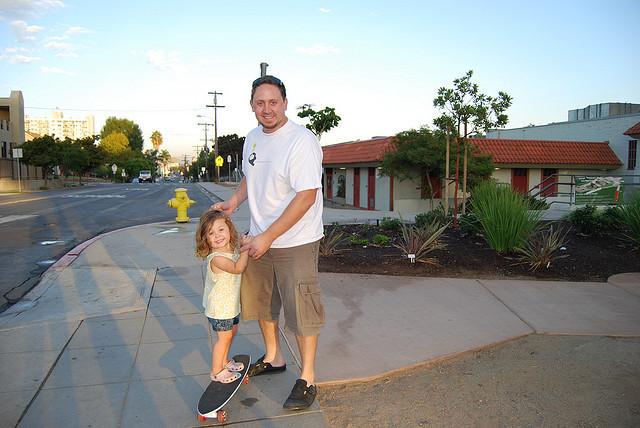What is he teaching her to do?
Write a very short answer. Skateboard. What type of shirt does the man wear?
Keep it brief. T-shirt. What is the man holding?
Concise answer only. Girl. What is this kid standing on?
Short answer required. Skateboard. How many of their shirts have blue in them?
Give a very brief answer. 0. 